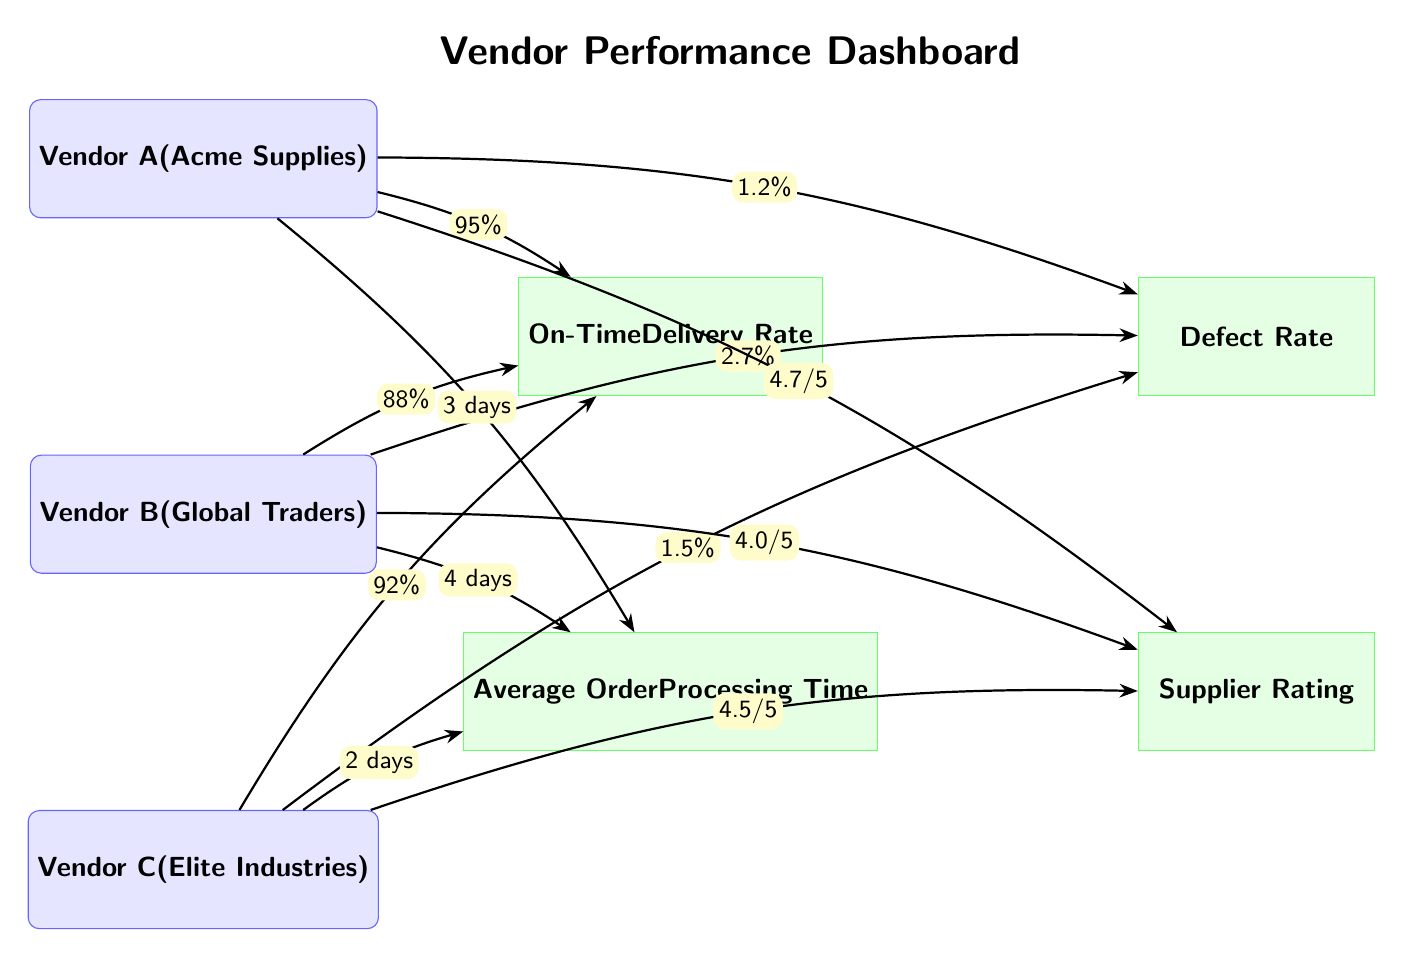What is the on-time delivery rate for Vendor A? The diagram indicates that the on-time delivery rate is represented by the arrow connected to Vendor A. According to the label on the arrow, Vendor A has a delivery rate of 95%.
Answer: 95% How many total vendors are displayed in the diagram? By counting the vendor nodes listed in the diagram, we find Vendor A, Vendor B, and Vendor C, making a total of three vendors.
Answer: 3 What is the defect rate of Vendor C? The defect rate is shown by the arrow connected to Vendor C. The corresponding label on this arrow shows that Vendor C has a defect rate of 1.5%.
Answer: 1.5% Which vendor has the highest supplier rating? To determine the highest supplier rating, we compare the ratings of all vendors as labeled on their respective connections. Vendor A has the highest rating at 4.7 out of 5.
Answer: 4.7/5 How does Vendor B's average order processing time compare to Vendor C's? To compare the average order processing time, we look at the values indicated for both vendors. Vendor B has an average order processing time of 4 days, while Vendor C has 2 days. Since 4 days is longer than 2 days, Vendor B's processing time is higher.
Answer: Vendor B has a longer processing time What is the average order processing time for Vendor A? The diagram details Vendor A’s average order processing time through the arrow connecting Vendor A to the respective KPI. The arrow shows that the processing time is 3 days.
Answer: 3 days What is the defect rate of Vendor B? The defect rate for Vendor B can be found from the arrow pointing to the defect rate KPI. The label on this arrow specifies that Vendor B has a defect rate of 2.7%.
Answer: 2.7% Which vendor has the lowest on-time delivery rate? For this question, we compare the on-time delivery rates of each vendor from their associated arrows. Vendor B has the lowest on-time delivery rate at 88%.
Answer: Vendor B What is the average order processing time for the vendor with the highest defect rate? First, we identify the defect rates for all vendors. Vendor B has the highest defect rate at 2.7%. We then find the average order processing time for Vendor B, which is 4 days.
Answer: 4 days 